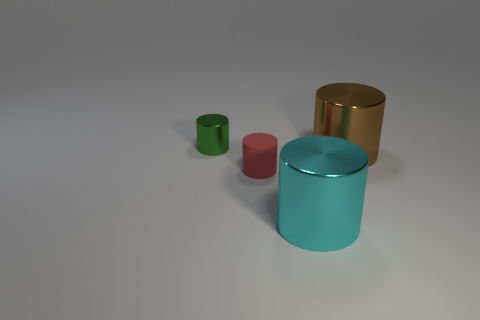What number of things are either large shiny cylinders that are behind the big cyan cylinder or metallic cylinders that are behind the red thing?
Offer a terse response. 2. Are there more cylinders right of the small green cylinder than brown metal objects to the right of the large brown thing?
Give a very brief answer. Yes. What number of cylinders are either green metallic objects or cyan objects?
Your answer should be very brief. 2. What number of objects are either shiny cylinders in front of the small green shiny thing or tiny gray metal things?
Offer a very short reply. 2. There is a large thing behind the small object that is in front of the shiny object that is behind the big brown shiny thing; what is its shape?
Keep it short and to the point. Cylinder. How many other large cyan things are the same shape as the rubber thing?
Provide a short and direct response. 1. Is the material of the green cylinder the same as the tiny red object?
Provide a short and direct response. No. What number of tiny red cylinders are on the left side of the tiny thing that is to the right of the tiny object that is behind the small red matte cylinder?
Keep it short and to the point. 0. Is there a brown cylinder made of the same material as the tiny red cylinder?
Keep it short and to the point. No. Are there fewer gray metallic things than large things?
Provide a short and direct response. Yes. 